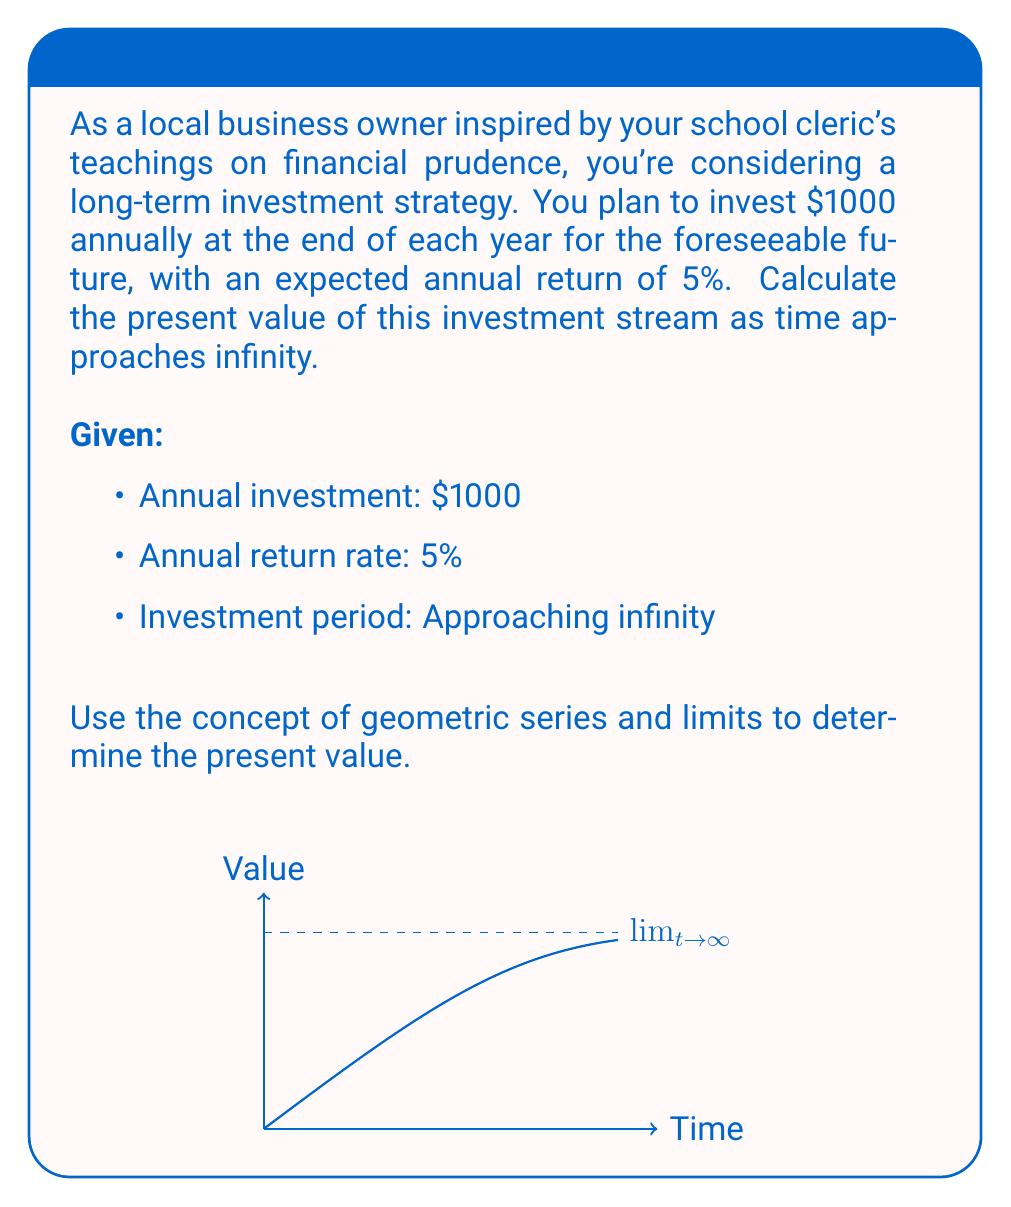Help me with this question. Let's approach this step-by-step:

1) First, we need to recognize that this is an infinite geometric series. The present value of each year's investment forms a geometric sequence.

2) The present value of the first year's investment (made at the end of the year) is:
   $$PV_1 = \frac{1000}{1.05^1} = \frac{1000}{1.05}$$

3) The present value of the second year's investment is:
   $$PV_2 = \frac{1000}{1.05^2}$$

4) In general, the present value of the nth year's investment is:
   $$PV_n = \frac{1000}{1.05^n}$$

5) The total present value is the sum of all these terms as n approaches infinity:
   $$PV_{total} = \sum_{n=1}^{\infty} \frac{1000}{1.05^n}$$

6) This is a geometric series with first term $a = \frac{1000}{1.05}$ and common ratio $r = \frac{1}{1.05}$

7) For an infinite geometric series with $|r| < 1$, the sum is given by $\frac{a}{1-r}$

8) In this case:
   $$PV_{total} = \frac{\frac{1000}{1.05}}{1-\frac{1}{1.05}} = \frac{1000}{1.05-1} = \frac{1000}{0.05} = 20000$$

Therefore, the present value of this infinite investment stream is $20,000.
Answer: $20,000 